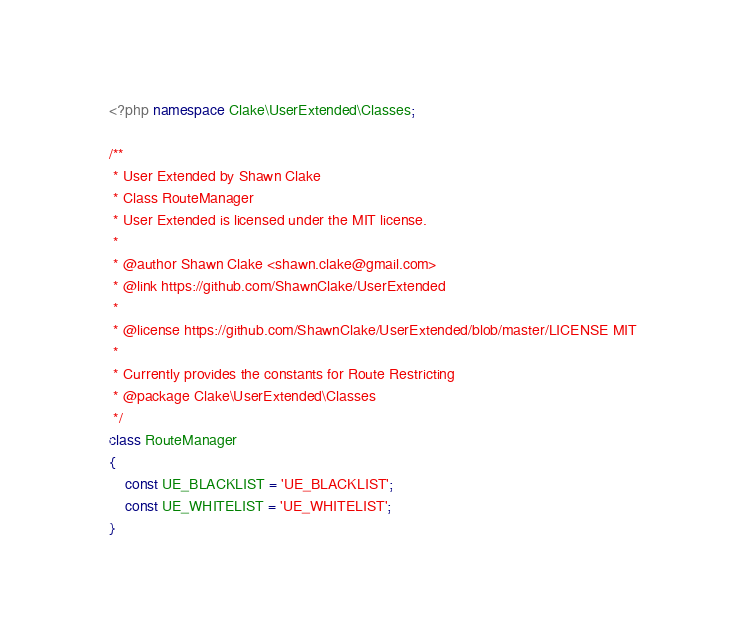Convert code to text. <code><loc_0><loc_0><loc_500><loc_500><_PHP_><?php namespace Clake\UserExtended\Classes;

/**
 * User Extended by Shawn Clake
 * Class RouteManager
 * User Extended is licensed under the MIT license.
 *
 * @author Shawn Clake <shawn.clake@gmail.com>
 * @link https://github.com/ShawnClake/UserExtended
 *
 * @license https://github.com/ShawnClake/UserExtended/blob/master/LICENSE MIT
 *
 * Currently provides the constants for Route Restricting
 * @package Clake\UserExtended\Classes
 */
class RouteManager
{
    const UE_BLACKLIST = 'UE_BLACKLIST';
    const UE_WHITELIST = 'UE_WHITELIST';
}</code> 